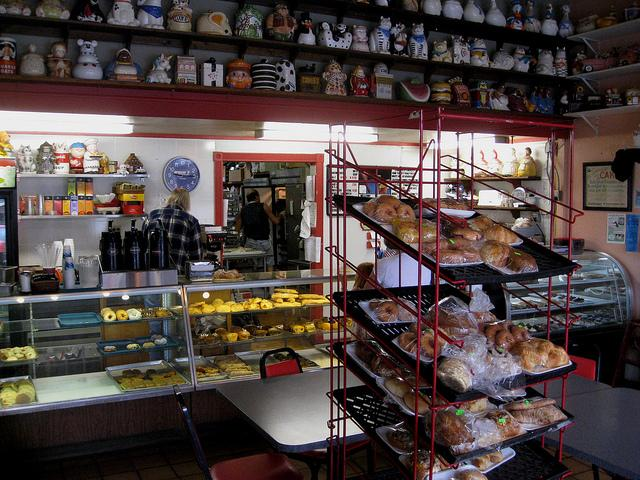What type of items are on the rack in front? baked goods 